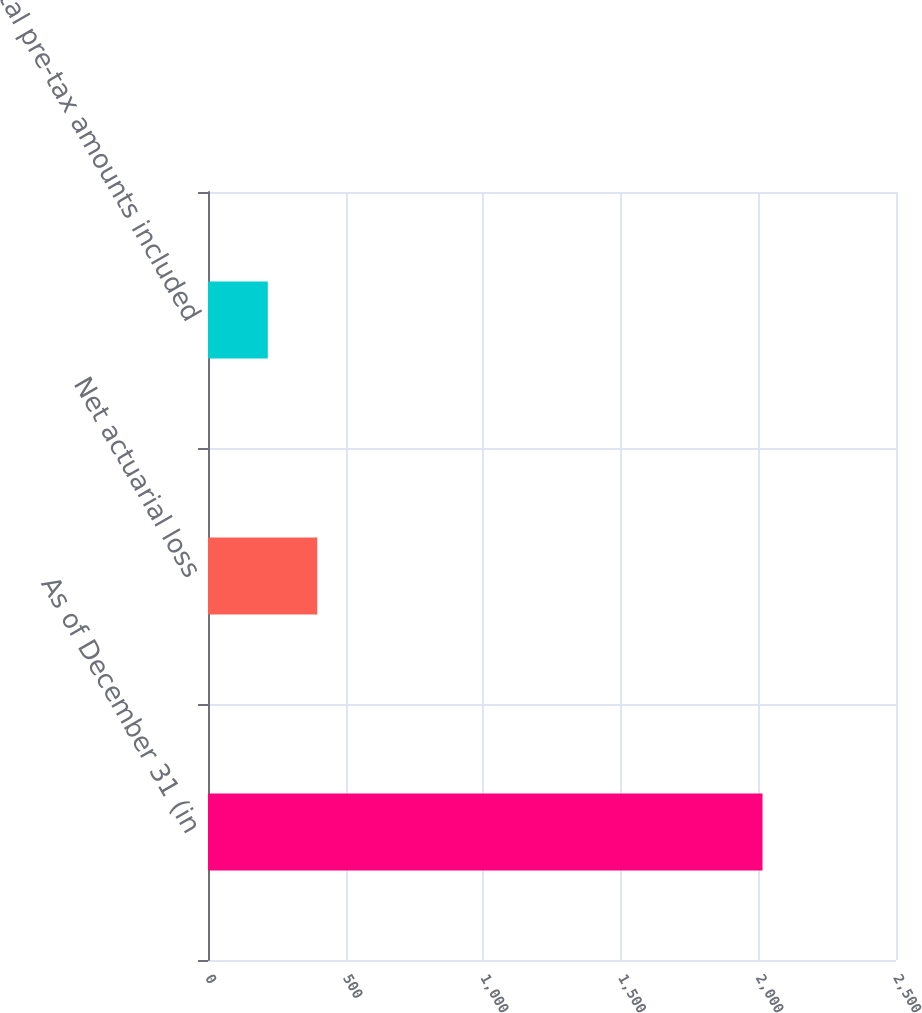<chart> <loc_0><loc_0><loc_500><loc_500><bar_chart><fcel>As of December 31 (in<fcel>Net actuarial loss<fcel>Total pre-tax amounts included<nl><fcel>2015<fcel>397.07<fcel>217.3<nl></chart> 